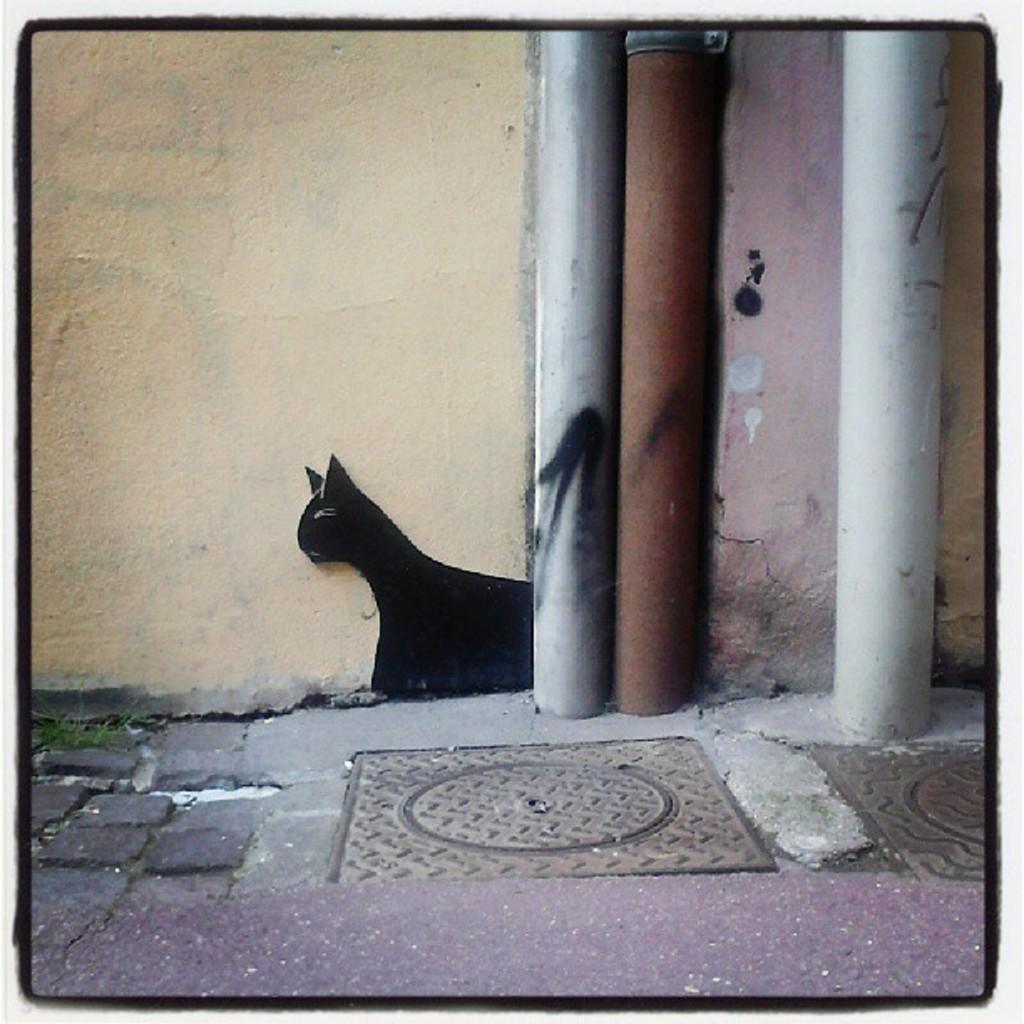How would you summarize this image in a sentence or two? In the foreground of this image, there are pipes, manhole on the ground and a cat sketch on the wall. 